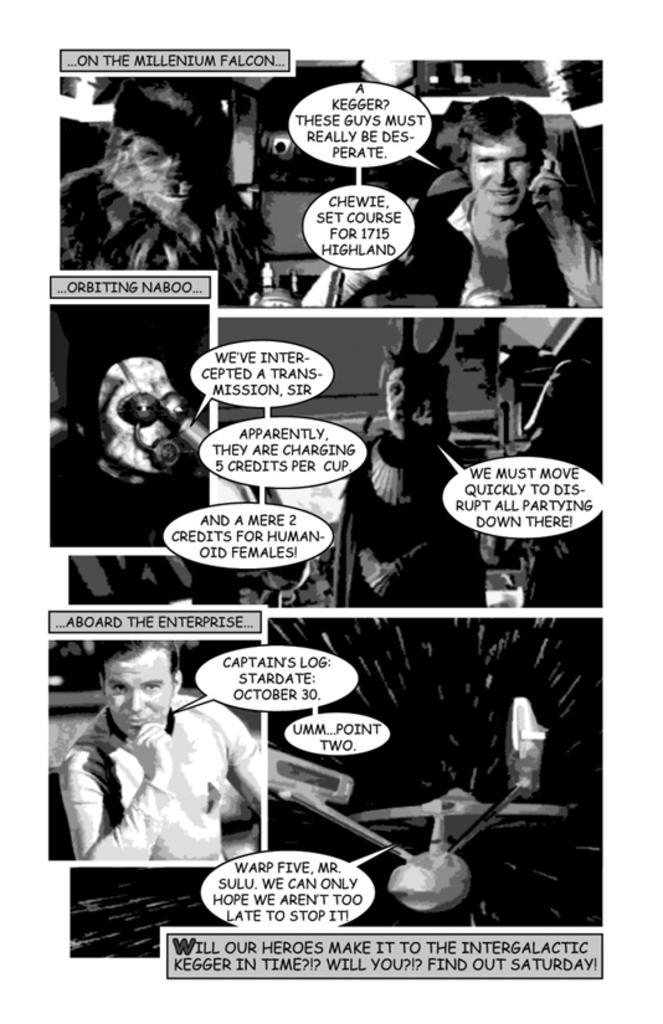What type of images are present in the image? There are collage pictures in the image. What can be seen in the collage pictures? The collage pictures contain people and an aircraft. Are there any words or letters on the collage pictures? Yes, there is text on the collage pictures. What is the price of the insurance policy shown in the image? There is no insurance policy or price mentioned in the image; it only contains collage pictures with people, an aircraft, and text. 